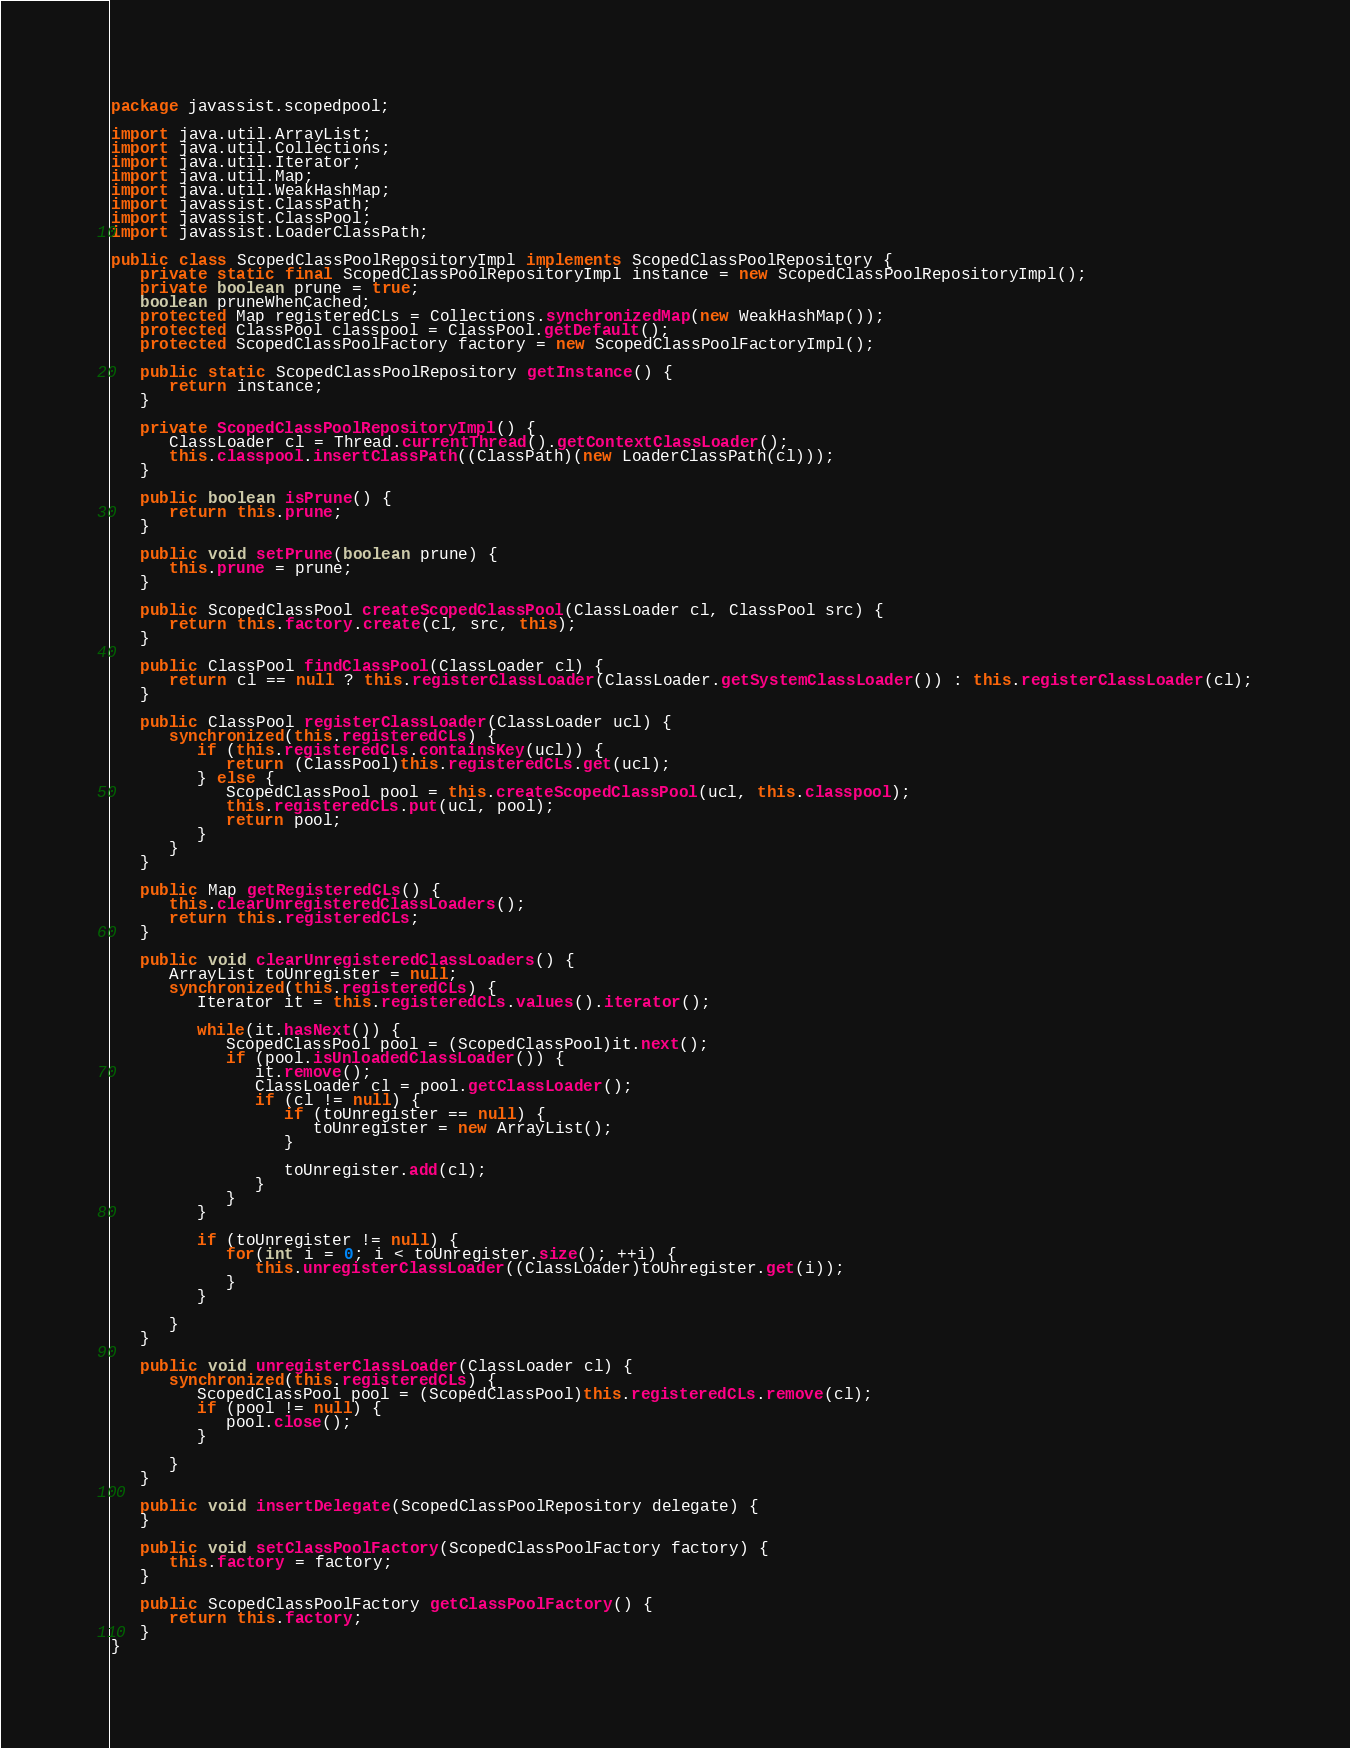Convert code to text. <code><loc_0><loc_0><loc_500><loc_500><_Java_>package javassist.scopedpool;

import java.util.ArrayList;
import java.util.Collections;
import java.util.Iterator;
import java.util.Map;
import java.util.WeakHashMap;
import javassist.ClassPath;
import javassist.ClassPool;
import javassist.LoaderClassPath;

public class ScopedClassPoolRepositoryImpl implements ScopedClassPoolRepository {
   private static final ScopedClassPoolRepositoryImpl instance = new ScopedClassPoolRepositoryImpl();
   private boolean prune = true;
   boolean pruneWhenCached;
   protected Map registeredCLs = Collections.synchronizedMap(new WeakHashMap());
   protected ClassPool classpool = ClassPool.getDefault();
   protected ScopedClassPoolFactory factory = new ScopedClassPoolFactoryImpl();

   public static ScopedClassPoolRepository getInstance() {
      return instance;
   }

   private ScopedClassPoolRepositoryImpl() {
      ClassLoader cl = Thread.currentThread().getContextClassLoader();
      this.classpool.insertClassPath((ClassPath)(new LoaderClassPath(cl)));
   }

   public boolean isPrune() {
      return this.prune;
   }

   public void setPrune(boolean prune) {
      this.prune = prune;
   }

   public ScopedClassPool createScopedClassPool(ClassLoader cl, ClassPool src) {
      return this.factory.create(cl, src, this);
   }

   public ClassPool findClassPool(ClassLoader cl) {
      return cl == null ? this.registerClassLoader(ClassLoader.getSystemClassLoader()) : this.registerClassLoader(cl);
   }

   public ClassPool registerClassLoader(ClassLoader ucl) {
      synchronized(this.registeredCLs) {
         if (this.registeredCLs.containsKey(ucl)) {
            return (ClassPool)this.registeredCLs.get(ucl);
         } else {
            ScopedClassPool pool = this.createScopedClassPool(ucl, this.classpool);
            this.registeredCLs.put(ucl, pool);
            return pool;
         }
      }
   }

   public Map getRegisteredCLs() {
      this.clearUnregisteredClassLoaders();
      return this.registeredCLs;
   }

   public void clearUnregisteredClassLoaders() {
      ArrayList toUnregister = null;
      synchronized(this.registeredCLs) {
         Iterator it = this.registeredCLs.values().iterator();

         while(it.hasNext()) {
            ScopedClassPool pool = (ScopedClassPool)it.next();
            if (pool.isUnloadedClassLoader()) {
               it.remove();
               ClassLoader cl = pool.getClassLoader();
               if (cl != null) {
                  if (toUnregister == null) {
                     toUnregister = new ArrayList();
                  }

                  toUnregister.add(cl);
               }
            }
         }

         if (toUnregister != null) {
            for(int i = 0; i < toUnregister.size(); ++i) {
               this.unregisterClassLoader((ClassLoader)toUnregister.get(i));
            }
         }

      }
   }

   public void unregisterClassLoader(ClassLoader cl) {
      synchronized(this.registeredCLs) {
         ScopedClassPool pool = (ScopedClassPool)this.registeredCLs.remove(cl);
         if (pool != null) {
            pool.close();
         }

      }
   }

   public void insertDelegate(ScopedClassPoolRepository delegate) {
   }

   public void setClassPoolFactory(ScopedClassPoolFactory factory) {
      this.factory = factory;
   }

   public ScopedClassPoolFactory getClassPoolFactory() {
      return this.factory;
   }
}
</code> 